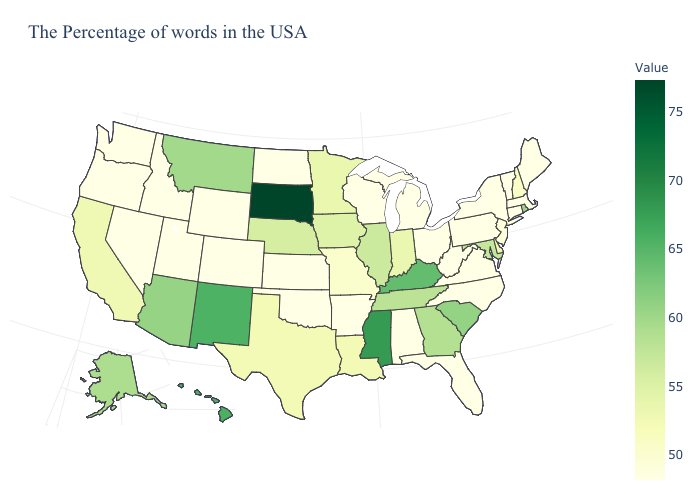Does Oklahoma have a higher value than Georgia?
Concise answer only. No. Which states have the lowest value in the USA?
Short answer required. Maine, Massachusetts, Vermont, Connecticut, New York, Pennsylvania, Virginia, North Carolina, West Virginia, Ohio, Florida, Michigan, Alabama, Wisconsin, Arkansas, Kansas, Oklahoma, North Dakota, Wyoming, Colorado, Utah, Idaho, Nevada, Washington, Oregon. 